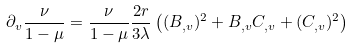<formula> <loc_0><loc_0><loc_500><loc_500>\partial _ { v } \frac { \nu } { 1 - \mu } = \frac { \nu } { 1 - \mu } \frac { 2 r } { 3 \lambda } \left ( ( B _ { , v } ) ^ { 2 } + B _ { , v } C _ { , v } + ( C _ { , v } ) ^ { 2 } \right )</formula> 